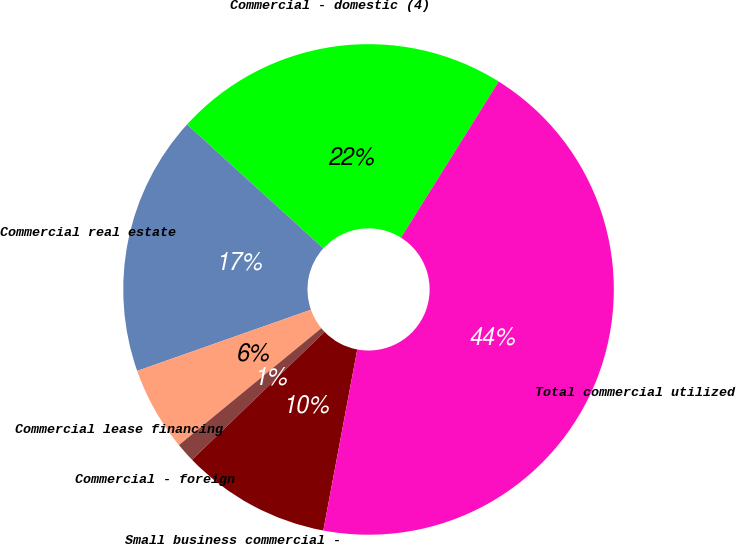Convert chart to OTSL. <chart><loc_0><loc_0><loc_500><loc_500><pie_chart><fcel>Commercial - domestic (4)<fcel>Commercial real estate<fcel>Commercial lease financing<fcel>Commercial - foreign<fcel>Small business commercial -<fcel>Total commercial utilized<nl><fcel>22.16%<fcel>17.13%<fcel>5.55%<fcel>1.28%<fcel>9.83%<fcel>44.05%<nl></chart> 